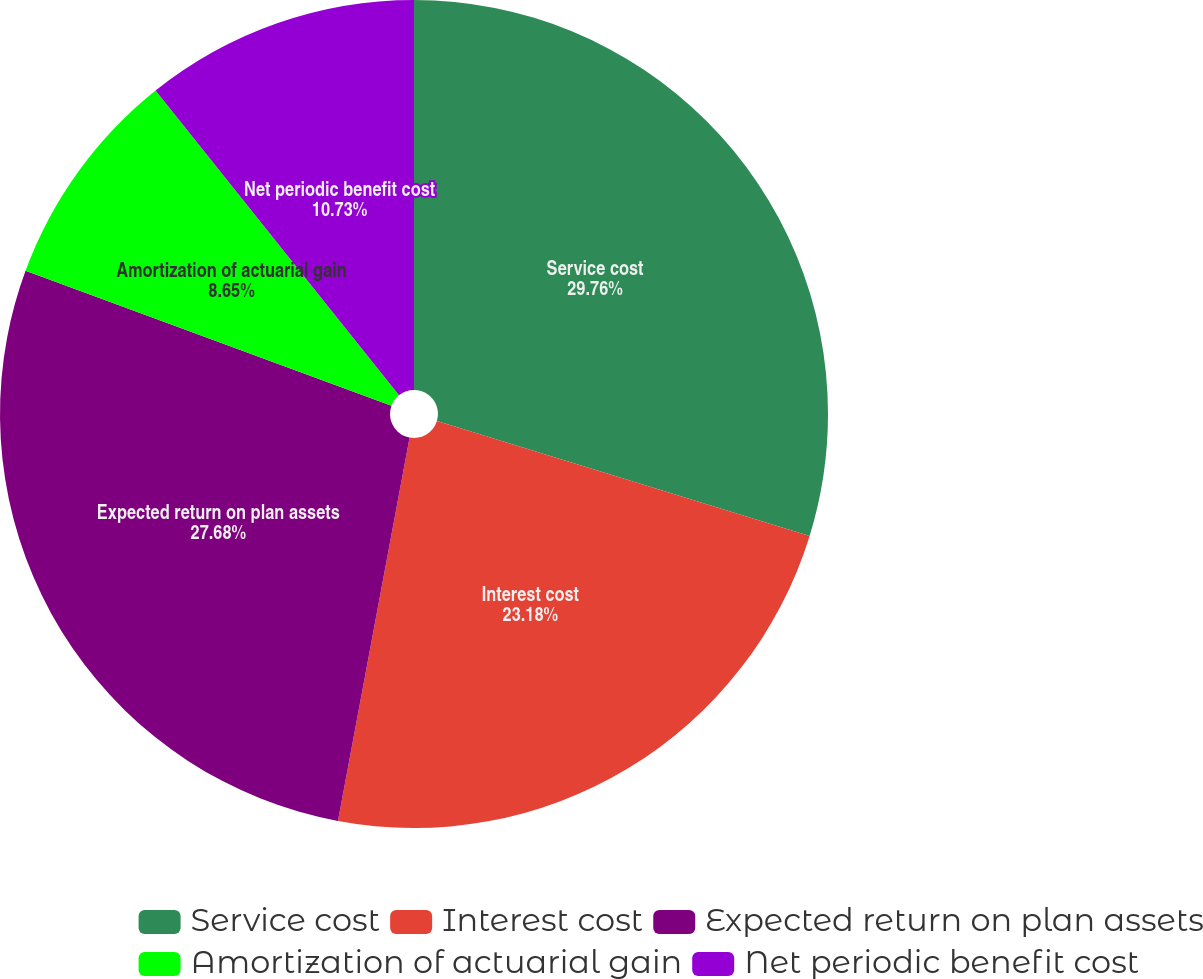<chart> <loc_0><loc_0><loc_500><loc_500><pie_chart><fcel>Service cost<fcel>Interest cost<fcel>Expected return on plan assets<fcel>Amortization of actuarial gain<fcel>Net periodic benefit cost<nl><fcel>29.76%<fcel>23.18%<fcel>27.68%<fcel>8.65%<fcel>10.73%<nl></chart> 